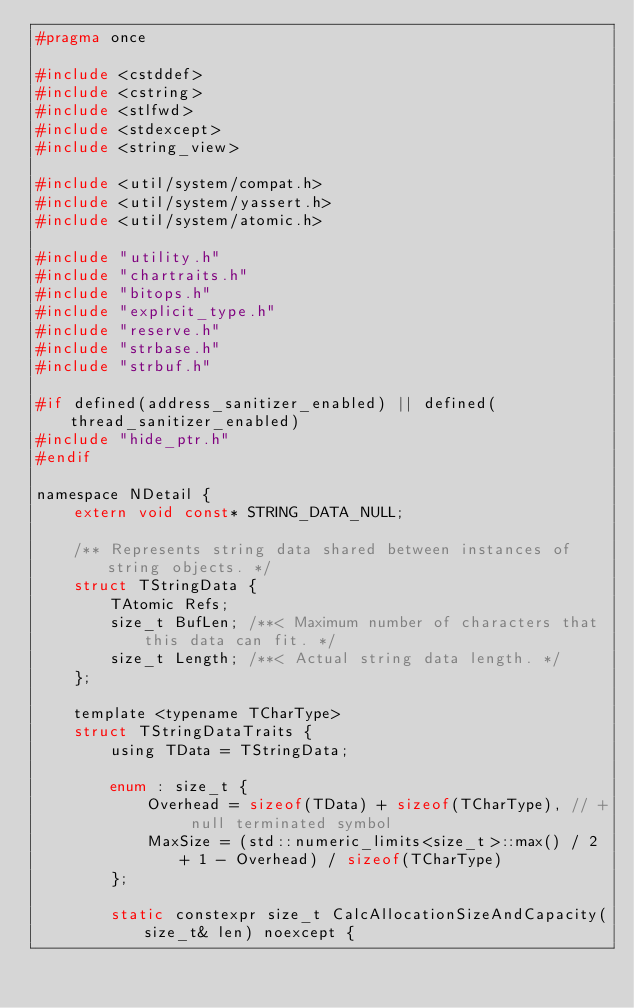Convert code to text. <code><loc_0><loc_0><loc_500><loc_500><_C_>#pragma once

#include <cstddef>
#include <cstring>
#include <stlfwd>
#include <stdexcept>
#include <string_view>

#include <util/system/compat.h>
#include <util/system/yassert.h>
#include <util/system/atomic.h>

#include "utility.h"
#include "chartraits.h"
#include "bitops.h"
#include "explicit_type.h"
#include "reserve.h"
#include "strbase.h"
#include "strbuf.h"

#if defined(address_sanitizer_enabled) || defined(thread_sanitizer_enabled)
#include "hide_ptr.h"
#endif

namespace NDetail {
    extern void const* STRING_DATA_NULL;

    /** Represents string data shared between instances of string objects. */
    struct TStringData {
        TAtomic Refs;
        size_t BufLen; /**< Maximum number of characters that this data can fit. */
        size_t Length; /**< Actual string data length. */
    };

    template <typename TCharType>
    struct TStringDataTraits {
        using TData = TStringData;

        enum : size_t {
            Overhead = sizeof(TData) + sizeof(TCharType), // + null terminated symbol
            MaxSize = (std::numeric_limits<size_t>::max() / 2 + 1 - Overhead) / sizeof(TCharType)
        };

        static constexpr size_t CalcAllocationSizeAndCapacity(size_t& len) noexcept {</code> 